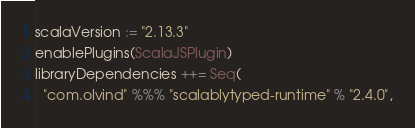<code> <loc_0><loc_0><loc_500><loc_500><_Scala_>scalaVersion := "2.13.3"
enablePlugins(ScalaJSPlugin)
libraryDependencies ++= Seq(
  "com.olvind" %%% "scalablytyped-runtime" % "2.4.0",</code> 